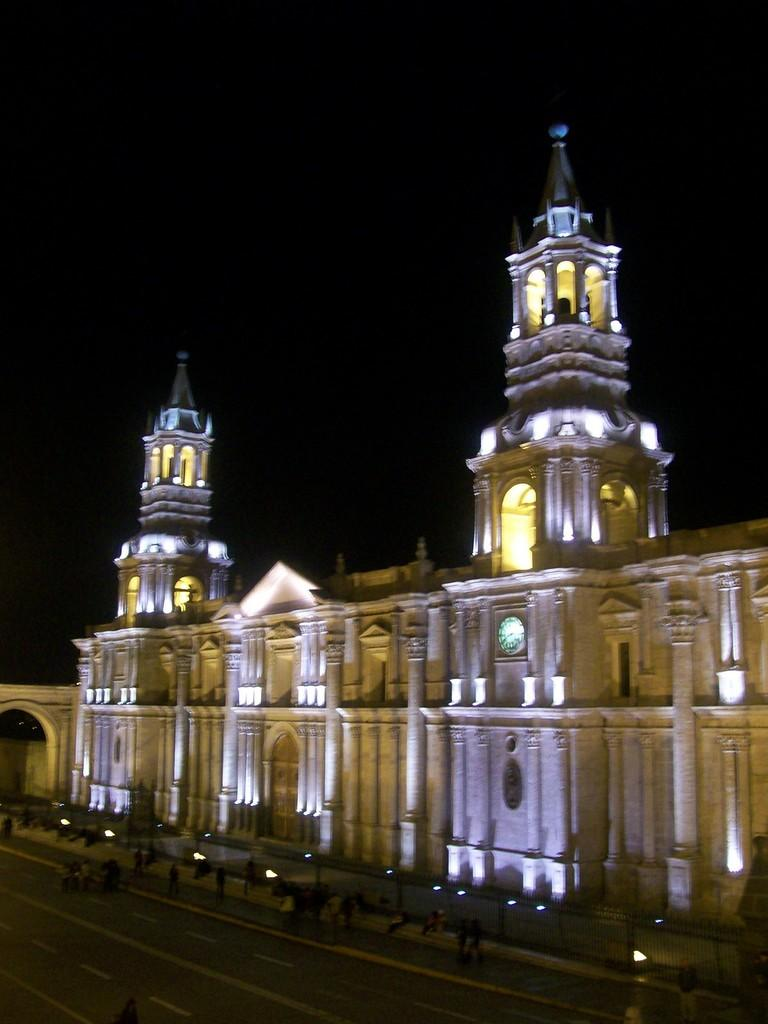What type of structure can be seen in the background of the image? There is a castle in the background of the image. Are there any people or figures in the image? Yes, there are persons in front of the castle. What type of engine is powering the house in the image? There is no house or engine present in the image; it features a castle and persons in front of it. 